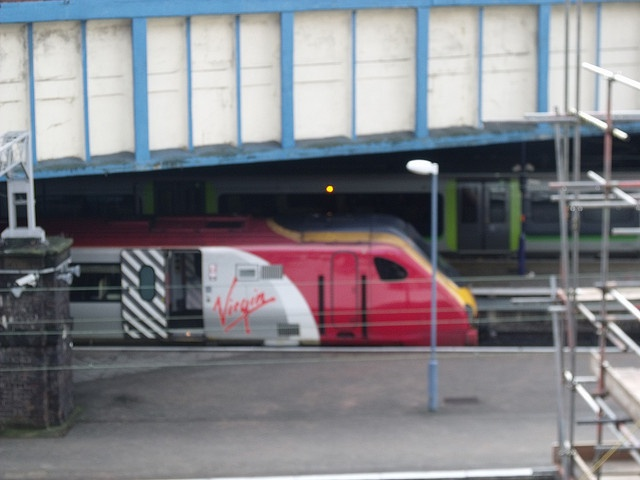Describe the objects in this image and their specific colors. I can see train in gray, black, brown, and darkgray tones and train in gray, black, and darkgreen tones in this image. 